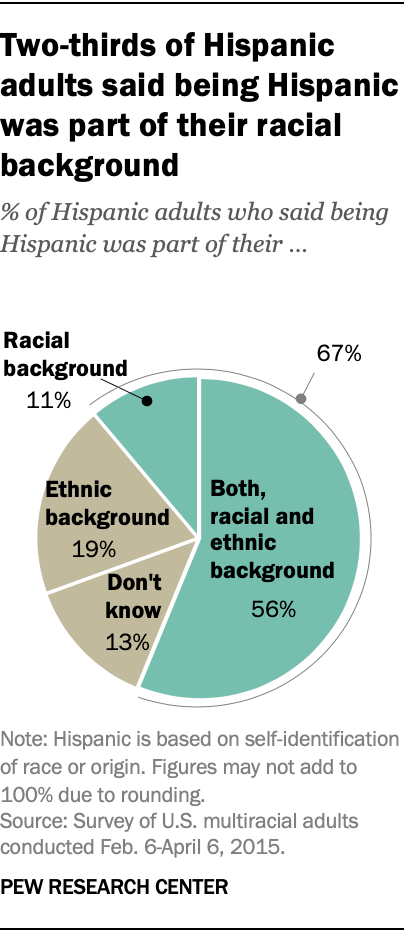Specify some key components in this picture. The three smallest slices of the graph add up to approximately 0.43. The racial background option has the smallest slice. 